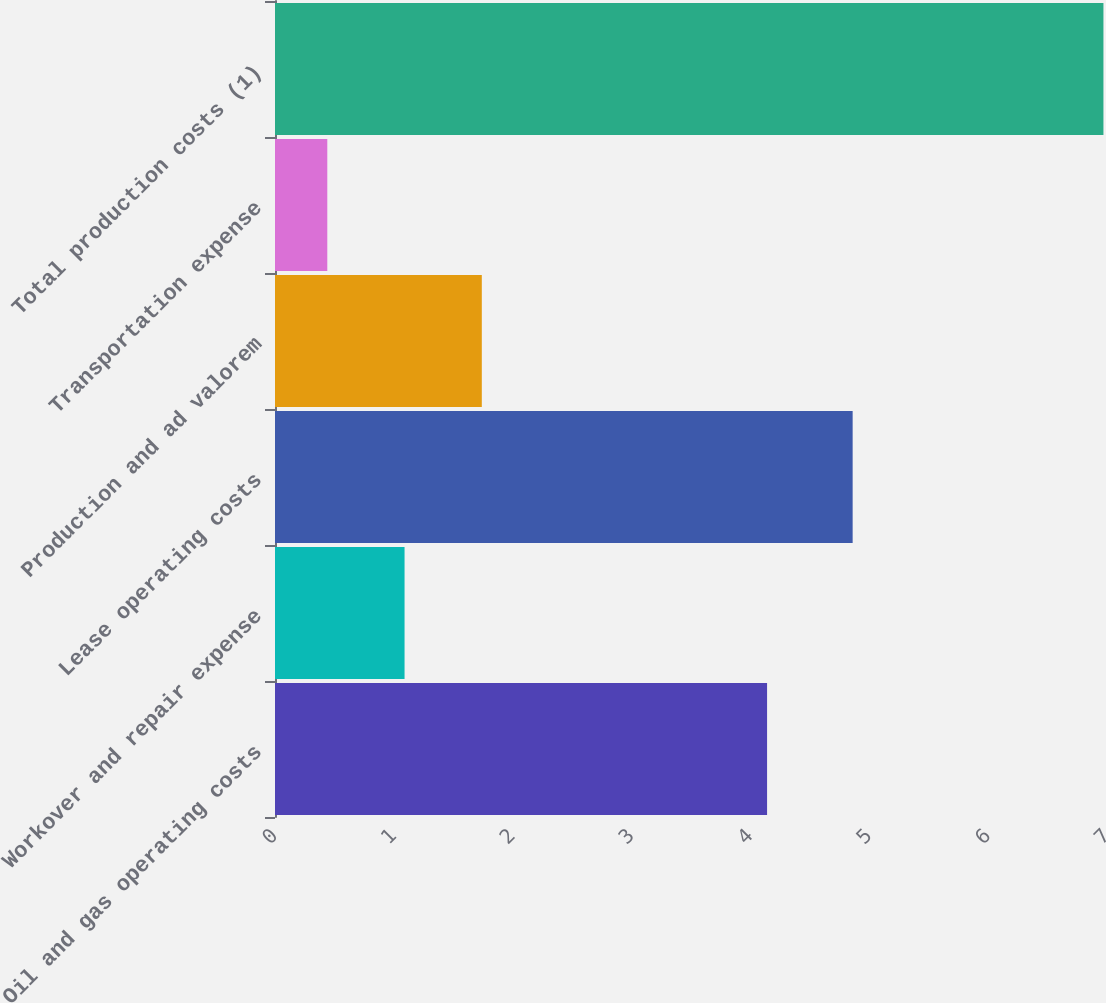<chart> <loc_0><loc_0><loc_500><loc_500><bar_chart><fcel>Oil and gas operating costs<fcel>Workover and repair expense<fcel>Lease operating costs<fcel>Production and ad valorem<fcel>Transportation expense<fcel>Total production costs (1)<nl><fcel>4.14<fcel>1.09<fcel>4.86<fcel>1.74<fcel>0.44<fcel>6.97<nl></chart> 